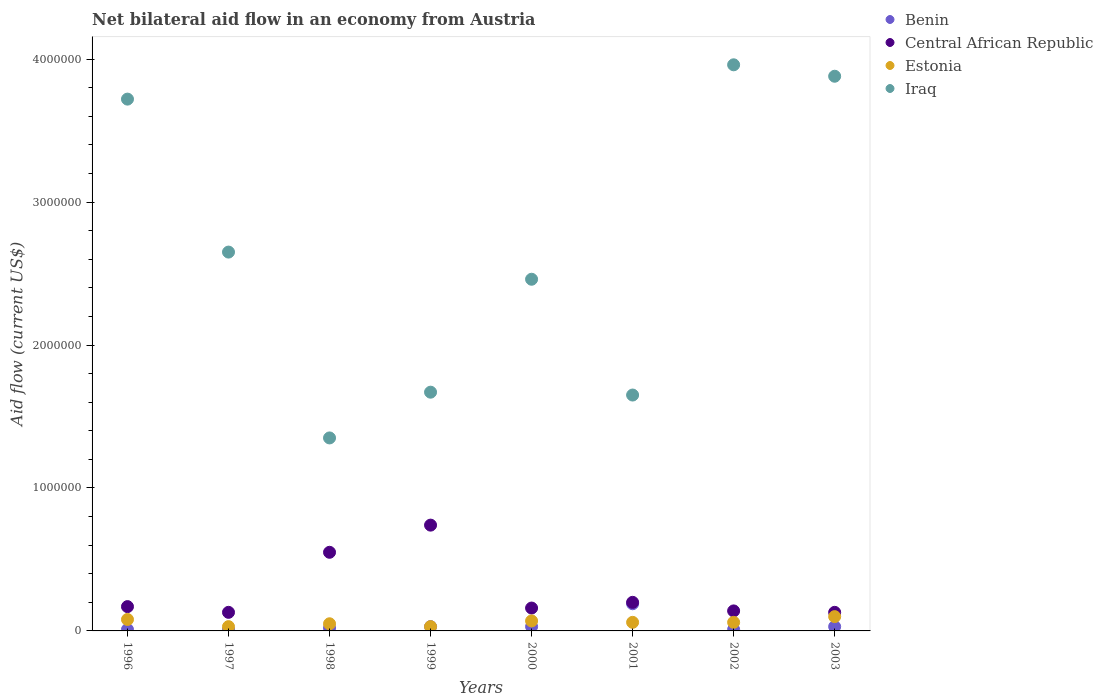How many different coloured dotlines are there?
Offer a very short reply. 4. Across all years, what is the maximum net bilateral aid flow in Central African Republic?
Your response must be concise. 7.40e+05. Across all years, what is the minimum net bilateral aid flow in Iraq?
Your response must be concise. 1.35e+06. What is the total net bilateral aid flow in Iraq in the graph?
Provide a succinct answer. 2.13e+07. What is the average net bilateral aid flow in Central African Republic per year?
Provide a succinct answer. 2.78e+05. In the year 1996, what is the difference between the net bilateral aid flow in Iraq and net bilateral aid flow in Benin?
Provide a succinct answer. 3.71e+06. In how many years, is the net bilateral aid flow in Central African Republic greater than 3800000 US$?
Ensure brevity in your answer.  0. What is the ratio of the net bilateral aid flow in Benin in 2001 to that in 2002?
Your response must be concise. 19. Is the net bilateral aid flow in Benin in 1998 less than that in 2003?
Provide a succinct answer. Yes. Is the difference between the net bilateral aid flow in Iraq in 1996 and 2002 greater than the difference between the net bilateral aid flow in Benin in 1996 and 2002?
Provide a short and direct response. No. What is the difference between the highest and the second highest net bilateral aid flow in Iraq?
Offer a terse response. 8.00e+04. What is the difference between the highest and the lowest net bilateral aid flow in Iraq?
Provide a succinct answer. 2.61e+06. Is the sum of the net bilateral aid flow in Central African Republic in 1996 and 1998 greater than the maximum net bilateral aid flow in Iraq across all years?
Offer a very short reply. No. Is it the case that in every year, the sum of the net bilateral aid flow in Iraq and net bilateral aid flow in Benin  is greater than the net bilateral aid flow in Central African Republic?
Your answer should be compact. Yes. How many dotlines are there?
Offer a very short reply. 4. How many years are there in the graph?
Provide a short and direct response. 8. What is the difference between two consecutive major ticks on the Y-axis?
Offer a terse response. 1.00e+06. Are the values on the major ticks of Y-axis written in scientific E-notation?
Ensure brevity in your answer.  No. Does the graph contain any zero values?
Give a very brief answer. No. How many legend labels are there?
Make the answer very short. 4. How are the legend labels stacked?
Your answer should be very brief. Vertical. What is the title of the graph?
Provide a short and direct response. Net bilateral aid flow in an economy from Austria. Does "Swaziland" appear as one of the legend labels in the graph?
Provide a succinct answer. No. What is the label or title of the X-axis?
Offer a terse response. Years. What is the Aid flow (current US$) of Benin in 1996?
Your answer should be very brief. 10000. What is the Aid flow (current US$) of Central African Republic in 1996?
Offer a terse response. 1.70e+05. What is the Aid flow (current US$) of Estonia in 1996?
Provide a succinct answer. 8.00e+04. What is the Aid flow (current US$) of Iraq in 1996?
Your response must be concise. 3.72e+06. What is the Aid flow (current US$) in Iraq in 1997?
Your response must be concise. 2.65e+06. What is the Aid flow (current US$) of Central African Republic in 1998?
Offer a very short reply. 5.50e+05. What is the Aid flow (current US$) in Iraq in 1998?
Offer a very short reply. 1.35e+06. What is the Aid flow (current US$) in Benin in 1999?
Offer a very short reply. 3.00e+04. What is the Aid flow (current US$) in Central African Republic in 1999?
Give a very brief answer. 7.40e+05. What is the Aid flow (current US$) of Iraq in 1999?
Keep it short and to the point. 1.67e+06. What is the Aid flow (current US$) in Benin in 2000?
Your answer should be compact. 3.00e+04. What is the Aid flow (current US$) in Central African Republic in 2000?
Provide a short and direct response. 1.60e+05. What is the Aid flow (current US$) in Iraq in 2000?
Offer a terse response. 2.46e+06. What is the Aid flow (current US$) of Central African Republic in 2001?
Offer a terse response. 2.00e+05. What is the Aid flow (current US$) in Estonia in 2001?
Offer a very short reply. 6.00e+04. What is the Aid flow (current US$) in Iraq in 2001?
Your answer should be very brief. 1.65e+06. What is the Aid flow (current US$) of Estonia in 2002?
Your answer should be very brief. 6.00e+04. What is the Aid flow (current US$) of Iraq in 2002?
Ensure brevity in your answer.  3.96e+06. What is the Aid flow (current US$) of Benin in 2003?
Give a very brief answer. 3.00e+04. What is the Aid flow (current US$) of Estonia in 2003?
Your answer should be very brief. 1.00e+05. What is the Aid flow (current US$) in Iraq in 2003?
Make the answer very short. 3.88e+06. Across all years, what is the maximum Aid flow (current US$) of Benin?
Provide a short and direct response. 1.90e+05. Across all years, what is the maximum Aid flow (current US$) in Central African Republic?
Offer a terse response. 7.40e+05. Across all years, what is the maximum Aid flow (current US$) in Estonia?
Make the answer very short. 1.00e+05. Across all years, what is the maximum Aid flow (current US$) of Iraq?
Your response must be concise. 3.96e+06. Across all years, what is the minimum Aid flow (current US$) of Estonia?
Your response must be concise. 3.00e+04. Across all years, what is the minimum Aid flow (current US$) of Iraq?
Your answer should be very brief. 1.35e+06. What is the total Aid flow (current US$) in Central African Republic in the graph?
Give a very brief answer. 2.22e+06. What is the total Aid flow (current US$) in Estonia in the graph?
Offer a very short reply. 4.80e+05. What is the total Aid flow (current US$) of Iraq in the graph?
Provide a succinct answer. 2.13e+07. What is the difference between the Aid flow (current US$) of Iraq in 1996 and that in 1997?
Offer a terse response. 1.07e+06. What is the difference between the Aid flow (current US$) of Central African Republic in 1996 and that in 1998?
Provide a short and direct response. -3.80e+05. What is the difference between the Aid flow (current US$) in Iraq in 1996 and that in 1998?
Your answer should be very brief. 2.37e+06. What is the difference between the Aid flow (current US$) of Benin in 1996 and that in 1999?
Your answer should be compact. -2.00e+04. What is the difference between the Aid flow (current US$) of Central African Republic in 1996 and that in 1999?
Keep it short and to the point. -5.70e+05. What is the difference between the Aid flow (current US$) of Iraq in 1996 and that in 1999?
Provide a succinct answer. 2.05e+06. What is the difference between the Aid flow (current US$) in Iraq in 1996 and that in 2000?
Give a very brief answer. 1.26e+06. What is the difference between the Aid flow (current US$) in Iraq in 1996 and that in 2001?
Make the answer very short. 2.07e+06. What is the difference between the Aid flow (current US$) of Central African Republic in 1996 and that in 2002?
Offer a terse response. 3.00e+04. What is the difference between the Aid flow (current US$) in Central African Republic in 1996 and that in 2003?
Make the answer very short. 4.00e+04. What is the difference between the Aid flow (current US$) in Benin in 1997 and that in 1998?
Provide a short and direct response. -10000. What is the difference between the Aid flow (current US$) in Central African Republic in 1997 and that in 1998?
Ensure brevity in your answer.  -4.20e+05. What is the difference between the Aid flow (current US$) of Iraq in 1997 and that in 1998?
Your answer should be very brief. 1.30e+06. What is the difference between the Aid flow (current US$) in Central African Republic in 1997 and that in 1999?
Keep it short and to the point. -6.10e+05. What is the difference between the Aid flow (current US$) in Estonia in 1997 and that in 1999?
Your response must be concise. 0. What is the difference between the Aid flow (current US$) in Iraq in 1997 and that in 1999?
Provide a succinct answer. 9.80e+05. What is the difference between the Aid flow (current US$) in Central African Republic in 1997 and that in 2000?
Provide a short and direct response. -3.00e+04. What is the difference between the Aid flow (current US$) of Iraq in 1997 and that in 2000?
Ensure brevity in your answer.  1.90e+05. What is the difference between the Aid flow (current US$) in Benin in 1997 and that in 2001?
Ensure brevity in your answer.  -1.80e+05. What is the difference between the Aid flow (current US$) of Central African Republic in 1997 and that in 2001?
Give a very brief answer. -7.00e+04. What is the difference between the Aid flow (current US$) in Iraq in 1997 and that in 2001?
Keep it short and to the point. 1.00e+06. What is the difference between the Aid flow (current US$) in Central African Republic in 1997 and that in 2002?
Your response must be concise. -10000. What is the difference between the Aid flow (current US$) of Iraq in 1997 and that in 2002?
Provide a succinct answer. -1.31e+06. What is the difference between the Aid flow (current US$) of Estonia in 1997 and that in 2003?
Offer a very short reply. -7.00e+04. What is the difference between the Aid flow (current US$) of Iraq in 1997 and that in 2003?
Give a very brief answer. -1.23e+06. What is the difference between the Aid flow (current US$) of Benin in 1998 and that in 1999?
Keep it short and to the point. -10000. What is the difference between the Aid flow (current US$) in Iraq in 1998 and that in 1999?
Your answer should be very brief. -3.20e+05. What is the difference between the Aid flow (current US$) of Iraq in 1998 and that in 2000?
Offer a terse response. -1.11e+06. What is the difference between the Aid flow (current US$) in Estonia in 1998 and that in 2001?
Offer a very short reply. -10000. What is the difference between the Aid flow (current US$) of Iraq in 1998 and that in 2001?
Your answer should be compact. -3.00e+05. What is the difference between the Aid flow (current US$) in Benin in 1998 and that in 2002?
Ensure brevity in your answer.  10000. What is the difference between the Aid flow (current US$) of Central African Republic in 1998 and that in 2002?
Ensure brevity in your answer.  4.10e+05. What is the difference between the Aid flow (current US$) in Iraq in 1998 and that in 2002?
Offer a terse response. -2.61e+06. What is the difference between the Aid flow (current US$) of Benin in 1998 and that in 2003?
Make the answer very short. -10000. What is the difference between the Aid flow (current US$) in Central African Republic in 1998 and that in 2003?
Your answer should be compact. 4.20e+05. What is the difference between the Aid flow (current US$) in Iraq in 1998 and that in 2003?
Make the answer very short. -2.53e+06. What is the difference between the Aid flow (current US$) of Benin in 1999 and that in 2000?
Your answer should be compact. 0. What is the difference between the Aid flow (current US$) of Central African Republic in 1999 and that in 2000?
Your answer should be compact. 5.80e+05. What is the difference between the Aid flow (current US$) of Estonia in 1999 and that in 2000?
Keep it short and to the point. -4.00e+04. What is the difference between the Aid flow (current US$) of Iraq in 1999 and that in 2000?
Make the answer very short. -7.90e+05. What is the difference between the Aid flow (current US$) of Central African Republic in 1999 and that in 2001?
Provide a short and direct response. 5.40e+05. What is the difference between the Aid flow (current US$) of Iraq in 1999 and that in 2001?
Provide a short and direct response. 2.00e+04. What is the difference between the Aid flow (current US$) of Estonia in 1999 and that in 2002?
Offer a terse response. -3.00e+04. What is the difference between the Aid flow (current US$) in Iraq in 1999 and that in 2002?
Ensure brevity in your answer.  -2.29e+06. What is the difference between the Aid flow (current US$) of Estonia in 1999 and that in 2003?
Provide a succinct answer. -7.00e+04. What is the difference between the Aid flow (current US$) in Iraq in 1999 and that in 2003?
Give a very brief answer. -2.21e+06. What is the difference between the Aid flow (current US$) of Iraq in 2000 and that in 2001?
Ensure brevity in your answer.  8.10e+05. What is the difference between the Aid flow (current US$) of Benin in 2000 and that in 2002?
Provide a short and direct response. 2.00e+04. What is the difference between the Aid flow (current US$) in Estonia in 2000 and that in 2002?
Your answer should be compact. 10000. What is the difference between the Aid flow (current US$) of Iraq in 2000 and that in 2002?
Make the answer very short. -1.50e+06. What is the difference between the Aid flow (current US$) of Benin in 2000 and that in 2003?
Keep it short and to the point. 0. What is the difference between the Aid flow (current US$) of Iraq in 2000 and that in 2003?
Provide a succinct answer. -1.42e+06. What is the difference between the Aid flow (current US$) of Benin in 2001 and that in 2002?
Provide a short and direct response. 1.80e+05. What is the difference between the Aid flow (current US$) in Central African Republic in 2001 and that in 2002?
Your answer should be very brief. 6.00e+04. What is the difference between the Aid flow (current US$) of Iraq in 2001 and that in 2002?
Keep it short and to the point. -2.31e+06. What is the difference between the Aid flow (current US$) of Estonia in 2001 and that in 2003?
Make the answer very short. -4.00e+04. What is the difference between the Aid flow (current US$) in Iraq in 2001 and that in 2003?
Offer a very short reply. -2.23e+06. What is the difference between the Aid flow (current US$) of Benin in 2002 and that in 2003?
Make the answer very short. -2.00e+04. What is the difference between the Aid flow (current US$) of Benin in 1996 and the Aid flow (current US$) of Estonia in 1997?
Your response must be concise. -2.00e+04. What is the difference between the Aid flow (current US$) of Benin in 1996 and the Aid flow (current US$) of Iraq in 1997?
Ensure brevity in your answer.  -2.64e+06. What is the difference between the Aid flow (current US$) in Central African Republic in 1996 and the Aid flow (current US$) in Estonia in 1997?
Keep it short and to the point. 1.40e+05. What is the difference between the Aid flow (current US$) in Central African Republic in 1996 and the Aid flow (current US$) in Iraq in 1997?
Offer a terse response. -2.48e+06. What is the difference between the Aid flow (current US$) of Estonia in 1996 and the Aid flow (current US$) of Iraq in 1997?
Make the answer very short. -2.57e+06. What is the difference between the Aid flow (current US$) in Benin in 1996 and the Aid flow (current US$) in Central African Republic in 1998?
Ensure brevity in your answer.  -5.40e+05. What is the difference between the Aid flow (current US$) of Benin in 1996 and the Aid flow (current US$) of Estonia in 1998?
Provide a short and direct response. -4.00e+04. What is the difference between the Aid flow (current US$) in Benin in 1996 and the Aid flow (current US$) in Iraq in 1998?
Ensure brevity in your answer.  -1.34e+06. What is the difference between the Aid flow (current US$) in Central African Republic in 1996 and the Aid flow (current US$) in Estonia in 1998?
Provide a short and direct response. 1.20e+05. What is the difference between the Aid flow (current US$) in Central African Republic in 1996 and the Aid flow (current US$) in Iraq in 1998?
Provide a short and direct response. -1.18e+06. What is the difference between the Aid flow (current US$) in Estonia in 1996 and the Aid flow (current US$) in Iraq in 1998?
Provide a short and direct response. -1.27e+06. What is the difference between the Aid flow (current US$) in Benin in 1996 and the Aid flow (current US$) in Central African Republic in 1999?
Keep it short and to the point. -7.30e+05. What is the difference between the Aid flow (current US$) in Benin in 1996 and the Aid flow (current US$) in Iraq in 1999?
Your answer should be very brief. -1.66e+06. What is the difference between the Aid flow (current US$) of Central African Republic in 1996 and the Aid flow (current US$) of Iraq in 1999?
Make the answer very short. -1.50e+06. What is the difference between the Aid flow (current US$) in Estonia in 1996 and the Aid flow (current US$) in Iraq in 1999?
Ensure brevity in your answer.  -1.59e+06. What is the difference between the Aid flow (current US$) in Benin in 1996 and the Aid flow (current US$) in Central African Republic in 2000?
Make the answer very short. -1.50e+05. What is the difference between the Aid flow (current US$) in Benin in 1996 and the Aid flow (current US$) in Estonia in 2000?
Ensure brevity in your answer.  -6.00e+04. What is the difference between the Aid flow (current US$) of Benin in 1996 and the Aid flow (current US$) of Iraq in 2000?
Your response must be concise. -2.45e+06. What is the difference between the Aid flow (current US$) in Central African Republic in 1996 and the Aid flow (current US$) in Iraq in 2000?
Give a very brief answer. -2.29e+06. What is the difference between the Aid flow (current US$) in Estonia in 1996 and the Aid flow (current US$) in Iraq in 2000?
Your answer should be compact. -2.38e+06. What is the difference between the Aid flow (current US$) of Benin in 1996 and the Aid flow (current US$) of Central African Republic in 2001?
Make the answer very short. -1.90e+05. What is the difference between the Aid flow (current US$) in Benin in 1996 and the Aid flow (current US$) in Iraq in 2001?
Provide a succinct answer. -1.64e+06. What is the difference between the Aid flow (current US$) in Central African Republic in 1996 and the Aid flow (current US$) in Estonia in 2001?
Your answer should be compact. 1.10e+05. What is the difference between the Aid flow (current US$) of Central African Republic in 1996 and the Aid flow (current US$) of Iraq in 2001?
Your response must be concise. -1.48e+06. What is the difference between the Aid flow (current US$) in Estonia in 1996 and the Aid flow (current US$) in Iraq in 2001?
Ensure brevity in your answer.  -1.57e+06. What is the difference between the Aid flow (current US$) of Benin in 1996 and the Aid flow (current US$) of Central African Republic in 2002?
Give a very brief answer. -1.30e+05. What is the difference between the Aid flow (current US$) in Benin in 1996 and the Aid flow (current US$) in Estonia in 2002?
Provide a succinct answer. -5.00e+04. What is the difference between the Aid flow (current US$) in Benin in 1996 and the Aid flow (current US$) in Iraq in 2002?
Keep it short and to the point. -3.95e+06. What is the difference between the Aid flow (current US$) in Central African Republic in 1996 and the Aid flow (current US$) in Estonia in 2002?
Your response must be concise. 1.10e+05. What is the difference between the Aid flow (current US$) of Central African Republic in 1996 and the Aid flow (current US$) of Iraq in 2002?
Provide a short and direct response. -3.79e+06. What is the difference between the Aid flow (current US$) in Estonia in 1996 and the Aid flow (current US$) in Iraq in 2002?
Your response must be concise. -3.88e+06. What is the difference between the Aid flow (current US$) in Benin in 1996 and the Aid flow (current US$) in Iraq in 2003?
Make the answer very short. -3.87e+06. What is the difference between the Aid flow (current US$) in Central African Republic in 1996 and the Aid flow (current US$) in Iraq in 2003?
Your answer should be very brief. -3.71e+06. What is the difference between the Aid flow (current US$) of Estonia in 1996 and the Aid flow (current US$) of Iraq in 2003?
Provide a succinct answer. -3.80e+06. What is the difference between the Aid flow (current US$) of Benin in 1997 and the Aid flow (current US$) of Central African Republic in 1998?
Provide a short and direct response. -5.40e+05. What is the difference between the Aid flow (current US$) of Benin in 1997 and the Aid flow (current US$) of Estonia in 1998?
Provide a short and direct response. -4.00e+04. What is the difference between the Aid flow (current US$) in Benin in 1997 and the Aid flow (current US$) in Iraq in 1998?
Make the answer very short. -1.34e+06. What is the difference between the Aid flow (current US$) in Central African Republic in 1997 and the Aid flow (current US$) in Estonia in 1998?
Give a very brief answer. 8.00e+04. What is the difference between the Aid flow (current US$) in Central African Republic in 1997 and the Aid flow (current US$) in Iraq in 1998?
Keep it short and to the point. -1.22e+06. What is the difference between the Aid flow (current US$) of Estonia in 1997 and the Aid flow (current US$) of Iraq in 1998?
Make the answer very short. -1.32e+06. What is the difference between the Aid flow (current US$) in Benin in 1997 and the Aid flow (current US$) in Central African Republic in 1999?
Keep it short and to the point. -7.30e+05. What is the difference between the Aid flow (current US$) of Benin in 1997 and the Aid flow (current US$) of Iraq in 1999?
Your response must be concise. -1.66e+06. What is the difference between the Aid flow (current US$) of Central African Republic in 1997 and the Aid flow (current US$) of Estonia in 1999?
Keep it short and to the point. 1.00e+05. What is the difference between the Aid flow (current US$) in Central African Republic in 1997 and the Aid flow (current US$) in Iraq in 1999?
Provide a short and direct response. -1.54e+06. What is the difference between the Aid flow (current US$) in Estonia in 1997 and the Aid flow (current US$) in Iraq in 1999?
Your answer should be very brief. -1.64e+06. What is the difference between the Aid flow (current US$) in Benin in 1997 and the Aid flow (current US$) in Central African Republic in 2000?
Provide a succinct answer. -1.50e+05. What is the difference between the Aid flow (current US$) in Benin in 1997 and the Aid flow (current US$) in Estonia in 2000?
Ensure brevity in your answer.  -6.00e+04. What is the difference between the Aid flow (current US$) of Benin in 1997 and the Aid flow (current US$) of Iraq in 2000?
Offer a terse response. -2.45e+06. What is the difference between the Aid flow (current US$) in Central African Republic in 1997 and the Aid flow (current US$) in Iraq in 2000?
Your answer should be very brief. -2.33e+06. What is the difference between the Aid flow (current US$) of Estonia in 1997 and the Aid flow (current US$) of Iraq in 2000?
Your response must be concise. -2.43e+06. What is the difference between the Aid flow (current US$) in Benin in 1997 and the Aid flow (current US$) in Central African Republic in 2001?
Your response must be concise. -1.90e+05. What is the difference between the Aid flow (current US$) in Benin in 1997 and the Aid flow (current US$) in Estonia in 2001?
Your answer should be very brief. -5.00e+04. What is the difference between the Aid flow (current US$) in Benin in 1997 and the Aid flow (current US$) in Iraq in 2001?
Offer a very short reply. -1.64e+06. What is the difference between the Aid flow (current US$) of Central African Republic in 1997 and the Aid flow (current US$) of Estonia in 2001?
Offer a terse response. 7.00e+04. What is the difference between the Aid flow (current US$) of Central African Republic in 1997 and the Aid flow (current US$) of Iraq in 2001?
Make the answer very short. -1.52e+06. What is the difference between the Aid flow (current US$) of Estonia in 1997 and the Aid flow (current US$) of Iraq in 2001?
Your response must be concise. -1.62e+06. What is the difference between the Aid flow (current US$) in Benin in 1997 and the Aid flow (current US$) in Iraq in 2002?
Provide a succinct answer. -3.95e+06. What is the difference between the Aid flow (current US$) in Central African Republic in 1997 and the Aid flow (current US$) in Iraq in 2002?
Offer a very short reply. -3.83e+06. What is the difference between the Aid flow (current US$) of Estonia in 1997 and the Aid flow (current US$) of Iraq in 2002?
Provide a succinct answer. -3.93e+06. What is the difference between the Aid flow (current US$) in Benin in 1997 and the Aid flow (current US$) in Estonia in 2003?
Give a very brief answer. -9.00e+04. What is the difference between the Aid flow (current US$) in Benin in 1997 and the Aid flow (current US$) in Iraq in 2003?
Your answer should be very brief. -3.87e+06. What is the difference between the Aid flow (current US$) of Central African Republic in 1997 and the Aid flow (current US$) of Iraq in 2003?
Your response must be concise. -3.75e+06. What is the difference between the Aid flow (current US$) in Estonia in 1997 and the Aid flow (current US$) in Iraq in 2003?
Ensure brevity in your answer.  -3.85e+06. What is the difference between the Aid flow (current US$) in Benin in 1998 and the Aid flow (current US$) in Central African Republic in 1999?
Give a very brief answer. -7.20e+05. What is the difference between the Aid flow (current US$) in Benin in 1998 and the Aid flow (current US$) in Estonia in 1999?
Your answer should be very brief. -10000. What is the difference between the Aid flow (current US$) in Benin in 1998 and the Aid flow (current US$) in Iraq in 1999?
Your answer should be compact. -1.65e+06. What is the difference between the Aid flow (current US$) of Central African Republic in 1998 and the Aid flow (current US$) of Estonia in 1999?
Make the answer very short. 5.20e+05. What is the difference between the Aid flow (current US$) of Central African Republic in 1998 and the Aid flow (current US$) of Iraq in 1999?
Provide a succinct answer. -1.12e+06. What is the difference between the Aid flow (current US$) of Estonia in 1998 and the Aid flow (current US$) of Iraq in 1999?
Make the answer very short. -1.62e+06. What is the difference between the Aid flow (current US$) of Benin in 1998 and the Aid flow (current US$) of Iraq in 2000?
Your answer should be very brief. -2.44e+06. What is the difference between the Aid flow (current US$) in Central African Republic in 1998 and the Aid flow (current US$) in Iraq in 2000?
Offer a terse response. -1.91e+06. What is the difference between the Aid flow (current US$) of Estonia in 1998 and the Aid flow (current US$) of Iraq in 2000?
Your answer should be very brief. -2.41e+06. What is the difference between the Aid flow (current US$) of Benin in 1998 and the Aid flow (current US$) of Iraq in 2001?
Make the answer very short. -1.63e+06. What is the difference between the Aid flow (current US$) in Central African Republic in 1998 and the Aid flow (current US$) in Estonia in 2001?
Give a very brief answer. 4.90e+05. What is the difference between the Aid flow (current US$) in Central African Republic in 1998 and the Aid flow (current US$) in Iraq in 2001?
Your answer should be very brief. -1.10e+06. What is the difference between the Aid flow (current US$) of Estonia in 1998 and the Aid flow (current US$) of Iraq in 2001?
Ensure brevity in your answer.  -1.60e+06. What is the difference between the Aid flow (current US$) of Benin in 1998 and the Aid flow (current US$) of Central African Republic in 2002?
Provide a succinct answer. -1.20e+05. What is the difference between the Aid flow (current US$) in Benin in 1998 and the Aid flow (current US$) in Iraq in 2002?
Provide a succinct answer. -3.94e+06. What is the difference between the Aid flow (current US$) in Central African Republic in 1998 and the Aid flow (current US$) in Estonia in 2002?
Your answer should be very brief. 4.90e+05. What is the difference between the Aid flow (current US$) of Central African Republic in 1998 and the Aid flow (current US$) of Iraq in 2002?
Your answer should be very brief. -3.41e+06. What is the difference between the Aid flow (current US$) of Estonia in 1998 and the Aid flow (current US$) of Iraq in 2002?
Offer a very short reply. -3.91e+06. What is the difference between the Aid flow (current US$) of Benin in 1998 and the Aid flow (current US$) of Central African Republic in 2003?
Ensure brevity in your answer.  -1.10e+05. What is the difference between the Aid flow (current US$) of Benin in 1998 and the Aid flow (current US$) of Iraq in 2003?
Ensure brevity in your answer.  -3.86e+06. What is the difference between the Aid flow (current US$) in Central African Republic in 1998 and the Aid flow (current US$) in Estonia in 2003?
Your answer should be compact. 4.50e+05. What is the difference between the Aid flow (current US$) in Central African Republic in 1998 and the Aid flow (current US$) in Iraq in 2003?
Your answer should be compact. -3.33e+06. What is the difference between the Aid flow (current US$) in Estonia in 1998 and the Aid flow (current US$) in Iraq in 2003?
Provide a succinct answer. -3.83e+06. What is the difference between the Aid flow (current US$) in Benin in 1999 and the Aid flow (current US$) in Central African Republic in 2000?
Provide a succinct answer. -1.30e+05. What is the difference between the Aid flow (current US$) of Benin in 1999 and the Aid flow (current US$) of Iraq in 2000?
Your response must be concise. -2.43e+06. What is the difference between the Aid flow (current US$) in Central African Republic in 1999 and the Aid flow (current US$) in Estonia in 2000?
Your response must be concise. 6.70e+05. What is the difference between the Aid flow (current US$) in Central African Republic in 1999 and the Aid flow (current US$) in Iraq in 2000?
Offer a terse response. -1.72e+06. What is the difference between the Aid flow (current US$) in Estonia in 1999 and the Aid flow (current US$) in Iraq in 2000?
Give a very brief answer. -2.43e+06. What is the difference between the Aid flow (current US$) of Benin in 1999 and the Aid flow (current US$) of Estonia in 2001?
Ensure brevity in your answer.  -3.00e+04. What is the difference between the Aid flow (current US$) in Benin in 1999 and the Aid flow (current US$) in Iraq in 2001?
Your response must be concise. -1.62e+06. What is the difference between the Aid flow (current US$) of Central African Republic in 1999 and the Aid flow (current US$) of Estonia in 2001?
Offer a terse response. 6.80e+05. What is the difference between the Aid flow (current US$) of Central African Republic in 1999 and the Aid flow (current US$) of Iraq in 2001?
Your response must be concise. -9.10e+05. What is the difference between the Aid flow (current US$) of Estonia in 1999 and the Aid flow (current US$) of Iraq in 2001?
Your answer should be very brief. -1.62e+06. What is the difference between the Aid flow (current US$) in Benin in 1999 and the Aid flow (current US$) in Iraq in 2002?
Give a very brief answer. -3.93e+06. What is the difference between the Aid flow (current US$) of Central African Republic in 1999 and the Aid flow (current US$) of Estonia in 2002?
Offer a very short reply. 6.80e+05. What is the difference between the Aid flow (current US$) of Central African Republic in 1999 and the Aid flow (current US$) of Iraq in 2002?
Ensure brevity in your answer.  -3.22e+06. What is the difference between the Aid flow (current US$) of Estonia in 1999 and the Aid flow (current US$) of Iraq in 2002?
Provide a short and direct response. -3.93e+06. What is the difference between the Aid flow (current US$) of Benin in 1999 and the Aid flow (current US$) of Central African Republic in 2003?
Your answer should be very brief. -1.00e+05. What is the difference between the Aid flow (current US$) of Benin in 1999 and the Aid flow (current US$) of Iraq in 2003?
Provide a short and direct response. -3.85e+06. What is the difference between the Aid flow (current US$) in Central African Republic in 1999 and the Aid flow (current US$) in Estonia in 2003?
Offer a very short reply. 6.40e+05. What is the difference between the Aid flow (current US$) in Central African Republic in 1999 and the Aid flow (current US$) in Iraq in 2003?
Your answer should be compact. -3.14e+06. What is the difference between the Aid flow (current US$) in Estonia in 1999 and the Aid flow (current US$) in Iraq in 2003?
Give a very brief answer. -3.85e+06. What is the difference between the Aid flow (current US$) in Benin in 2000 and the Aid flow (current US$) in Central African Republic in 2001?
Offer a very short reply. -1.70e+05. What is the difference between the Aid flow (current US$) in Benin in 2000 and the Aid flow (current US$) in Estonia in 2001?
Give a very brief answer. -3.00e+04. What is the difference between the Aid flow (current US$) of Benin in 2000 and the Aid flow (current US$) of Iraq in 2001?
Make the answer very short. -1.62e+06. What is the difference between the Aid flow (current US$) in Central African Republic in 2000 and the Aid flow (current US$) in Estonia in 2001?
Provide a short and direct response. 1.00e+05. What is the difference between the Aid flow (current US$) in Central African Republic in 2000 and the Aid flow (current US$) in Iraq in 2001?
Offer a very short reply. -1.49e+06. What is the difference between the Aid flow (current US$) of Estonia in 2000 and the Aid flow (current US$) of Iraq in 2001?
Your answer should be compact. -1.58e+06. What is the difference between the Aid flow (current US$) in Benin in 2000 and the Aid flow (current US$) in Iraq in 2002?
Keep it short and to the point. -3.93e+06. What is the difference between the Aid flow (current US$) in Central African Republic in 2000 and the Aid flow (current US$) in Iraq in 2002?
Give a very brief answer. -3.80e+06. What is the difference between the Aid flow (current US$) in Estonia in 2000 and the Aid flow (current US$) in Iraq in 2002?
Your response must be concise. -3.89e+06. What is the difference between the Aid flow (current US$) of Benin in 2000 and the Aid flow (current US$) of Iraq in 2003?
Provide a succinct answer. -3.85e+06. What is the difference between the Aid flow (current US$) in Central African Republic in 2000 and the Aid flow (current US$) in Iraq in 2003?
Your answer should be very brief. -3.72e+06. What is the difference between the Aid flow (current US$) in Estonia in 2000 and the Aid flow (current US$) in Iraq in 2003?
Your answer should be very brief. -3.81e+06. What is the difference between the Aid flow (current US$) in Benin in 2001 and the Aid flow (current US$) in Central African Republic in 2002?
Make the answer very short. 5.00e+04. What is the difference between the Aid flow (current US$) in Benin in 2001 and the Aid flow (current US$) in Iraq in 2002?
Ensure brevity in your answer.  -3.77e+06. What is the difference between the Aid flow (current US$) of Central African Republic in 2001 and the Aid flow (current US$) of Estonia in 2002?
Your answer should be very brief. 1.40e+05. What is the difference between the Aid flow (current US$) in Central African Republic in 2001 and the Aid flow (current US$) in Iraq in 2002?
Offer a very short reply. -3.76e+06. What is the difference between the Aid flow (current US$) in Estonia in 2001 and the Aid flow (current US$) in Iraq in 2002?
Your answer should be compact. -3.90e+06. What is the difference between the Aid flow (current US$) of Benin in 2001 and the Aid flow (current US$) of Central African Republic in 2003?
Provide a short and direct response. 6.00e+04. What is the difference between the Aid flow (current US$) in Benin in 2001 and the Aid flow (current US$) in Estonia in 2003?
Keep it short and to the point. 9.00e+04. What is the difference between the Aid flow (current US$) of Benin in 2001 and the Aid flow (current US$) of Iraq in 2003?
Give a very brief answer. -3.69e+06. What is the difference between the Aid flow (current US$) in Central African Republic in 2001 and the Aid flow (current US$) in Iraq in 2003?
Ensure brevity in your answer.  -3.68e+06. What is the difference between the Aid flow (current US$) in Estonia in 2001 and the Aid flow (current US$) in Iraq in 2003?
Provide a succinct answer. -3.82e+06. What is the difference between the Aid flow (current US$) of Benin in 2002 and the Aid flow (current US$) of Central African Republic in 2003?
Provide a short and direct response. -1.20e+05. What is the difference between the Aid flow (current US$) in Benin in 2002 and the Aid flow (current US$) in Estonia in 2003?
Offer a terse response. -9.00e+04. What is the difference between the Aid flow (current US$) in Benin in 2002 and the Aid flow (current US$) in Iraq in 2003?
Provide a succinct answer. -3.87e+06. What is the difference between the Aid flow (current US$) of Central African Republic in 2002 and the Aid flow (current US$) of Estonia in 2003?
Keep it short and to the point. 4.00e+04. What is the difference between the Aid flow (current US$) of Central African Republic in 2002 and the Aid flow (current US$) of Iraq in 2003?
Ensure brevity in your answer.  -3.74e+06. What is the difference between the Aid flow (current US$) of Estonia in 2002 and the Aid flow (current US$) of Iraq in 2003?
Offer a very short reply. -3.82e+06. What is the average Aid flow (current US$) of Benin per year?
Ensure brevity in your answer.  4.12e+04. What is the average Aid flow (current US$) of Central African Republic per year?
Ensure brevity in your answer.  2.78e+05. What is the average Aid flow (current US$) of Estonia per year?
Provide a succinct answer. 6.00e+04. What is the average Aid flow (current US$) in Iraq per year?
Provide a succinct answer. 2.67e+06. In the year 1996, what is the difference between the Aid flow (current US$) in Benin and Aid flow (current US$) in Central African Republic?
Give a very brief answer. -1.60e+05. In the year 1996, what is the difference between the Aid flow (current US$) in Benin and Aid flow (current US$) in Estonia?
Offer a terse response. -7.00e+04. In the year 1996, what is the difference between the Aid flow (current US$) of Benin and Aid flow (current US$) of Iraq?
Your answer should be very brief. -3.71e+06. In the year 1996, what is the difference between the Aid flow (current US$) in Central African Republic and Aid flow (current US$) in Iraq?
Offer a terse response. -3.55e+06. In the year 1996, what is the difference between the Aid flow (current US$) in Estonia and Aid flow (current US$) in Iraq?
Ensure brevity in your answer.  -3.64e+06. In the year 1997, what is the difference between the Aid flow (current US$) of Benin and Aid flow (current US$) of Central African Republic?
Offer a very short reply. -1.20e+05. In the year 1997, what is the difference between the Aid flow (current US$) of Benin and Aid flow (current US$) of Estonia?
Provide a short and direct response. -2.00e+04. In the year 1997, what is the difference between the Aid flow (current US$) of Benin and Aid flow (current US$) of Iraq?
Ensure brevity in your answer.  -2.64e+06. In the year 1997, what is the difference between the Aid flow (current US$) in Central African Republic and Aid flow (current US$) in Iraq?
Offer a terse response. -2.52e+06. In the year 1997, what is the difference between the Aid flow (current US$) of Estonia and Aid flow (current US$) of Iraq?
Provide a succinct answer. -2.62e+06. In the year 1998, what is the difference between the Aid flow (current US$) in Benin and Aid flow (current US$) in Central African Republic?
Make the answer very short. -5.30e+05. In the year 1998, what is the difference between the Aid flow (current US$) in Benin and Aid flow (current US$) in Estonia?
Give a very brief answer. -3.00e+04. In the year 1998, what is the difference between the Aid flow (current US$) of Benin and Aid flow (current US$) of Iraq?
Provide a short and direct response. -1.33e+06. In the year 1998, what is the difference between the Aid flow (current US$) of Central African Republic and Aid flow (current US$) of Iraq?
Your answer should be very brief. -8.00e+05. In the year 1998, what is the difference between the Aid flow (current US$) in Estonia and Aid flow (current US$) in Iraq?
Your answer should be very brief. -1.30e+06. In the year 1999, what is the difference between the Aid flow (current US$) of Benin and Aid flow (current US$) of Central African Republic?
Your response must be concise. -7.10e+05. In the year 1999, what is the difference between the Aid flow (current US$) of Benin and Aid flow (current US$) of Iraq?
Your answer should be very brief. -1.64e+06. In the year 1999, what is the difference between the Aid flow (current US$) in Central African Republic and Aid flow (current US$) in Estonia?
Offer a very short reply. 7.10e+05. In the year 1999, what is the difference between the Aid flow (current US$) of Central African Republic and Aid flow (current US$) of Iraq?
Make the answer very short. -9.30e+05. In the year 1999, what is the difference between the Aid flow (current US$) of Estonia and Aid flow (current US$) of Iraq?
Keep it short and to the point. -1.64e+06. In the year 2000, what is the difference between the Aid flow (current US$) in Benin and Aid flow (current US$) in Central African Republic?
Keep it short and to the point. -1.30e+05. In the year 2000, what is the difference between the Aid flow (current US$) in Benin and Aid flow (current US$) in Estonia?
Offer a very short reply. -4.00e+04. In the year 2000, what is the difference between the Aid flow (current US$) of Benin and Aid flow (current US$) of Iraq?
Offer a terse response. -2.43e+06. In the year 2000, what is the difference between the Aid flow (current US$) in Central African Republic and Aid flow (current US$) in Estonia?
Offer a terse response. 9.00e+04. In the year 2000, what is the difference between the Aid flow (current US$) of Central African Republic and Aid flow (current US$) of Iraq?
Offer a very short reply. -2.30e+06. In the year 2000, what is the difference between the Aid flow (current US$) in Estonia and Aid flow (current US$) in Iraq?
Make the answer very short. -2.39e+06. In the year 2001, what is the difference between the Aid flow (current US$) of Benin and Aid flow (current US$) of Estonia?
Provide a short and direct response. 1.30e+05. In the year 2001, what is the difference between the Aid flow (current US$) in Benin and Aid flow (current US$) in Iraq?
Ensure brevity in your answer.  -1.46e+06. In the year 2001, what is the difference between the Aid flow (current US$) of Central African Republic and Aid flow (current US$) of Estonia?
Offer a very short reply. 1.40e+05. In the year 2001, what is the difference between the Aid flow (current US$) in Central African Republic and Aid flow (current US$) in Iraq?
Your response must be concise. -1.45e+06. In the year 2001, what is the difference between the Aid flow (current US$) of Estonia and Aid flow (current US$) of Iraq?
Your answer should be compact. -1.59e+06. In the year 2002, what is the difference between the Aid flow (current US$) in Benin and Aid flow (current US$) in Estonia?
Offer a very short reply. -5.00e+04. In the year 2002, what is the difference between the Aid flow (current US$) in Benin and Aid flow (current US$) in Iraq?
Keep it short and to the point. -3.95e+06. In the year 2002, what is the difference between the Aid flow (current US$) in Central African Republic and Aid flow (current US$) in Iraq?
Provide a succinct answer. -3.82e+06. In the year 2002, what is the difference between the Aid flow (current US$) in Estonia and Aid flow (current US$) in Iraq?
Give a very brief answer. -3.90e+06. In the year 2003, what is the difference between the Aid flow (current US$) of Benin and Aid flow (current US$) of Central African Republic?
Offer a terse response. -1.00e+05. In the year 2003, what is the difference between the Aid flow (current US$) of Benin and Aid flow (current US$) of Estonia?
Provide a short and direct response. -7.00e+04. In the year 2003, what is the difference between the Aid flow (current US$) of Benin and Aid flow (current US$) of Iraq?
Keep it short and to the point. -3.85e+06. In the year 2003, what is the difference between the Aid flow (current US$) in Central African Republic and Aid flow (current US$) in Estonia?
Provide a succinct answer. 3.00e+04. In the year 2003, what is the difference between the Aid flow (current US$) in Central African Republic and Aid flow (current US$) in Iraq?
Keep it short and to the point. -3.75e+06. In the year 2003, what is the difference between the Aid flow (current US$) of Estonia and Aid flow (current US$) of Iraq?
Offer a terse response. -3.78e+06. What is the ratio of the Aid flow (current US$) in Central African Republic in 1996 to that in 1997?
Make the answer very short. 1.31. What is the ratio of the Aid flow (current US$) in Estonia in 1996 to that in 1997?
Your response must be concise. 2.67. What is the ratio of the Aid flow (current US$) of Iraq in 1996 to that in 1997?
Give a very brief answer. 1.4. What is the ratio of the Aid flow (current US$) in Benin in 1996 to that in 1998?
Your answer should be very brief. 0.5. What is the ratio of the Aid flow (current US$) of Central African Republic in 1996 to that in 1998?
Your response must be concise. 0.31. What is the ratio of the Aid flow (current US$) in Estonia in 1996 to that in 1998?
Your answer should be compact. 1.6. What is the ratio of the Aid flow (current US$) of Iraq in 1996 to that in 1998?
Keep it short and to the point. 2.76. What is the ratio of the Aid flow (current US$) in Central African Republic in 1996 to that in 1999?
Provide a short and direct response. 0.23. What is the ratio of the Aid flow (current US$) in Estonia in 1996 to that in 1999?
Your response must be concise. 2.67. What is the ratio of the Aid flow (current US$) of Iraq in 1996 to that in 1999?
Your response must be concise. 2.23. What is the ratio of the Aid flow (current US$) in Benin in 1996 to that in 2000?
Your response must be concise. 0.33. What is the ratio of the Aid flow (current US$) of Central African Republic in 1996 to that in 2000?
Provide a short and direct response. 1.06. What is the ratio of the Aid flow (current US$) of Estonia in 1996 to that in 2000?
Provide a short and direct response. 1.14. What is the ratio of the Aid flow (current US$) in Iraq in 1996 to that in 2000?
Your answer should be compact. 1.51. What is the ratio of the Aid flow (current US$) of Benin in 1996 to that in 2001?
Give a very brief answer. 0.05. What is the ratio of the Aid flow (current US$) of Central African Republic in 1996 to that in 2001?
Your answer should be very brief. 0.85. What is the ratio of the Aid flow (current US$) in Iraq in 1996 to that in 2001?
Ensure brevity in your answer.  2.25. What is the ratio of the Aid flow (current US$) of Central African Republic in 1996 to that in 2002?
Provide a succinct answer. 1.21. What is the ratio of the Aid flow (current US$) of Iraq in 1996 to that in 2002?
Give a very brief answer. 0.94. What is the ratio of the Aid flow (current US$) in Central African Republic in 1996 to that in 2003?
Give a very brief answer. 1.31. What is the ratio of the Aid flow (current US$) of Estonia in 1996 to that in 2003?
Your answer should be very brief. 0.8. What is the ratio of the Aid flow (current US$) of Iraq in 1996 to that in 2003?
Your response must be concise. 0.96. What is the ratio of the Aid flow (current US$) of Central African Republic in 1997 to that in 1998?
Your answer should be very brief. 0.24. What is the ratio of the Aid flow (current US$) of Estonia in 1997 to that in 1998?
Offer a terse response. 0.6. What is the ratio of the Aid flow (current US$) of Iraq in 1997 to that in 1998?
Make the answer very short. 1.96. What is the ratio of the Aid flow (current US$) of Central African Republic in 1997 to that in 1999?
Offer a very short reply. 0.18. What is the ratio of the Aid flow (current US$) in Estonia in 1997 to that in 1999?
Provide a short and direct response. 1. What is the ratio of the Aid flow (current US$) of Iraq in 1997 to that in 1999?
Your answer should be very brief. 1.59. What is the ratio of the Aid flow (current US$) of Central African Republic in 1997 to that in 2000?
Your answer should be very brief. 0.81. What is the ratio of the Aid flow (current US$) of Estonia in 1997 to that in 2000?
Offer a very short reply. 0.43. What is the ratio of the Aid flow (current US$) in Iraq in 1997 to that in 2000?
Offer a terse response. 1.08. What is the ratio of the Aid flow (current US$) of Benin in 1997 to that in 2001?
Make the answer very short. 0.05. What is the ratio of the Aid flow (current US$) in Central African Republic in 1997 to that in 2001?
Give a very brief answer. 0.65. What is the ratio of the Aid flow (current US$) in Estonia in 1997 to that in 2001?
Offer a very short reply. 0.5. What is the ratio of the Aid flow (current US$) in Iraq in 1997 to that in 2001?
Your response must be concise. 1.61. What is the ratio of the Aid flow (current US$) in Benin in 1997 to that in 2002?
Offer a very short reply. 1. What is the ratio of the Aid flow (current US$) of Central African Republic in 1997 to that in 2002?
Your answer should be very brief. 0.93. What is the ratio of the Aid flow (current US$) in Iraq in 1997 to that in 2002?
Give a very brief answer. 0.67. What is the ratio of the Aid flow (current US$) of Benin in 1997 to that in 2003?
Offer a very short reply. 0.33. What is the ratio of the Aid flow (current US$) of Iraq in 1997 to that in 2003?
Your response must be concise. 0.68. What is the ratio of the Aid flow (current US$) in Benin in 1998 to that in 1999?
Provide a short and direct response. 0.67. What is the ratio of the Aid flow (current US$) of Central African Republic in 1998 to that in 1999?
Ensure brevity in your answer.  0.74. What is the ratio of the Aid flow (current US$) in Estonia in 1998 to that in 1999?
Provide a succinct answer. 1.67. What is the ratio of the Aid flow (current US$) in Iraq in 1998 to that in 1999?
Keep it short and to the point. 0.81. What is the ratio of the Aid flow (current US$) of Central African Republic in 1998 to that in 2000?
Your response must be concise. 3.44. What is the ratio of the Aid flow (current US$) of Estonia in 1998 to that in 2000?
Your answer should be very brief. 0.71. What is the ratio of the Aid flow (current US$) in Iraq in 1998 to that in 2000?
Ensure brevity in your answer.  0.55. What is the ratio of the Aid flow (current US$) of Benin in 1998 to that in 2001?
Your response must be concise. 0.11. What is the ratio of the Aid flow (current US$) of Central African Republic in 1998 to that in 2001?
Provide a succinct answer. 2.75. What is the ratio of the Aid flow (current US$) of Iraq in 1998 to that in 2001?
Offer a terse response. 0.82. What is the ratio of the Aid flow (current US$) in Benin in 1998 to that in 2002?
Offer a very short reply. 2. What is the ratio of the Aid flow (current US$) in Central African Republic in 1998 to that in 2002?
Your response must be concise. 3.93. What is the ratio of the Aid flow (current US$) of Estonia in 1998 to that in 2002?
Keep it short and to the point. 0.83. What is the ratio of the Aid flow (current US$) in Iraq in 1998 to that in 2002?
Offer a terse response. 0.34. What is the ratio of the Aid flow (current US$) in Benin in 1998 to that in 2003?
Your answer should be very brief. 0.67. What is the ratio of the Aid flow (current US$) in Central African Republic in 1998 to that in 2003?
Keep it short and to the point. 4.23. What is the ratio of the Aid flow (current US$) in Iraq in 1998 to that in 2003?
Provide a succinct answer. 0.35. What is the ratio of the Aid flow (current US$) in Central African Republic in 1999 to that in 2000?
Offer a terse response. 4.62. What is the ratio of the Aid flow (current US$) in Estonia in 1999 to that in 2000?
Provide a succinct answer. 0.43. What is the ratio of the Aid flow (current US$) of Iraq in 1999 to that in 2000?
Offer a very short reply. 0.68. What is the ratio of the Aid flow (current US$) of Benin in 1999 to that in 2001?
Give a very brief answer. 0.16. What is the ratio of the Aid flow (current US$) in Central African Republic in 1999 to that in 2001?
Ensure brevity in your answer.  3.7. What is the ratio of the Aid flow (current US$) of Iraq in 1999 to that in 2001?
Provide a short and direct response. 1.01. What is the ratio of the Aid flow (current US$) of Benin in 1999 to that in 2002?
Your answer should be compact. 3. What is the ratio of the Aid flow (current US$) in Central African Republic in 1999 to that in 2002?
Your response must be concise. 5.29. What is the ratio of the Aid flow (current US$) in Iraq in 1999 to that in 2002?
Provide a succinct answer. 0.42. What is the ratio of the Aid flow (current US$) of Central African Republic in 1999 to that in 2003?
Your answer should be compact. 5.69. What is the ratio of the Aid flow (current US$) of Estonia in 1999 to that in 2003?
Give a very brief answer. 0.3. What is the ratio of the Aid flow (current US$) of Iraq in 1999 to that in 2003?
Offer a very short reply. 0.43. What is the ratio of the Aid flow (current US$) in Benin in 2000 to that in 2001?
Provide a short and direct response. 0.16. What is the ratio of the Aid flow (current US$) of Estonia in 2000 to that in 2001?
Your response must be concise. 1.17. What is the ratio of the Aid flow (current US$) of Iraq in 2000 to that in 2001?
Ensure brevity in your answer.  1.49. What is the ratio of the Aid flow (current US$) of Central African Republic in 2000 to that in 2002?
Your answer should be compact. 1.14. What is the ratio of the Aid flow (current US$) of Estonia in 2000 to that in 2002?
Give a very brief answer. 1.17. What is the ratio of the Aid flow (current US$) in Iraq in 2000 to that in 2002?
Your answer should be compact. 0.62. What is the ratio of the Aid flow (current US$) of Benin in 2000 to that in 2003?
Provide a succinct answer. 1. What is the ratio of the Aid flow (current US$) in Central African Republic in 2000 to that in 2003?
Your answer should be compact. 1.23. What is the ratio of the Aid flow (current US$) in Estonia in 2000 to that in 2003?
Keep it short and to the point. 0.7. What is the ratio of the Aid flow (current US$) in Iraq in 2000 to that in 2003?
Your answer should be very brief. 0.63. What is the ratio of the Aid flow (current US$) in Benin in 2001 to that in 2002?
Your response must be concise. 19. What is the ratio of the Aid flow (current US$) of Central African Republic in 2001 to that in 2002?
Provide a succinct answer. 1.43. What is the ratio of the Aid flow (current US$) in Iraq in 2001 to that in 2002?
Your answer should be compact. 0.42. What is the ratio of the Aid flow (current US$) of Benin in 2001 to that in 2003?
Keep it short and to the point. 6.33. What is the ratio of the Aid flow (current US$) of Central African Republic in 2001 to that in 2003?
Ensure brevity in your answer.  1.54. What is the ratio of the Aid flow (current US$) of Estonia in 2001 to that in 2003?
Offer a very short reply. 0.6. What is the ratio of the Aid flow (current US$) in Iraq in 2001 to that in 2003?
Offer a very short reply. 0.43. What is the ratio of the Aid flow (current US$) in Benin in 2002 to that in 2003?
Make the answer very short. 0.33. What is the ratio of the Aid flow (current US$) of Central African Republic in 2002 to that in 2003?
Your response must be concise. 1.08. What is the ratio of the Aid flow (current US$) in Iraq in 2002 to that in 2003?
Offer a very short reply. 1.02. What is the difference between the highest and the second highest Aid flow (current US$) of Benin?
Your answer should be very brief. 1.60e+05. What is the difference between the highest and the second highest Aid flow (current US$) in Estonia?
Make the answer very short. 2.00e+04. What is the difference between the highest and the lowest Aid flow (current US$) of Benin?
Provide a succinct answer. 1.80e+05. What is the difference between the highest and the lowest Aid flow (current US$) in Estonia?
Your answer should be compact. 7.00e+04. What is the difference between the highest and the lowest Aid flow (current US$) of Iraq?
Your response must be concise. 2.61e+06. 